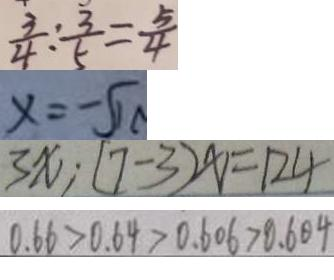<formula> <loc_0><loc_0><loc_500><loc_500>\frac { 3 } { 4 } : \frac { 3 } { 5 } = \frac { 5 } { 4 } 
 x = - \sqrt { 1 0 } 
 3 x \cdot ( 7 - 3 ) x = 1 2 4 
 0 . 6 6 > 0 . 6 4 > 0 . 6 0 6 > 0 . 6 0 4</formula> 